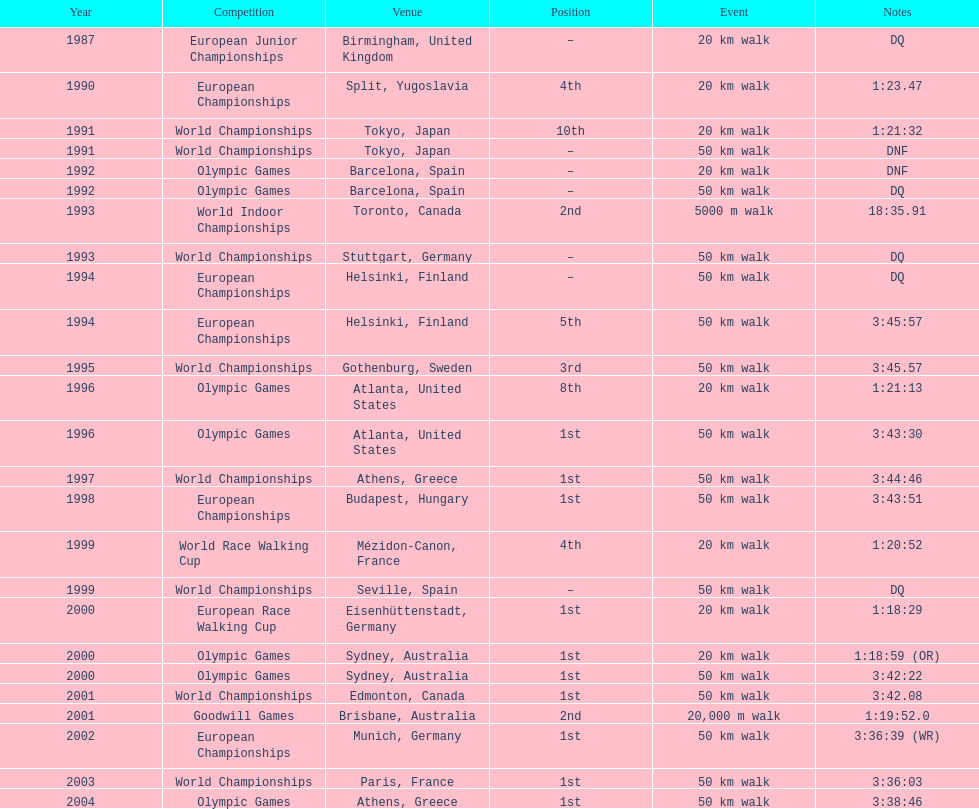On how many occasions did korzeniowski rank better than fourth place? 13. 